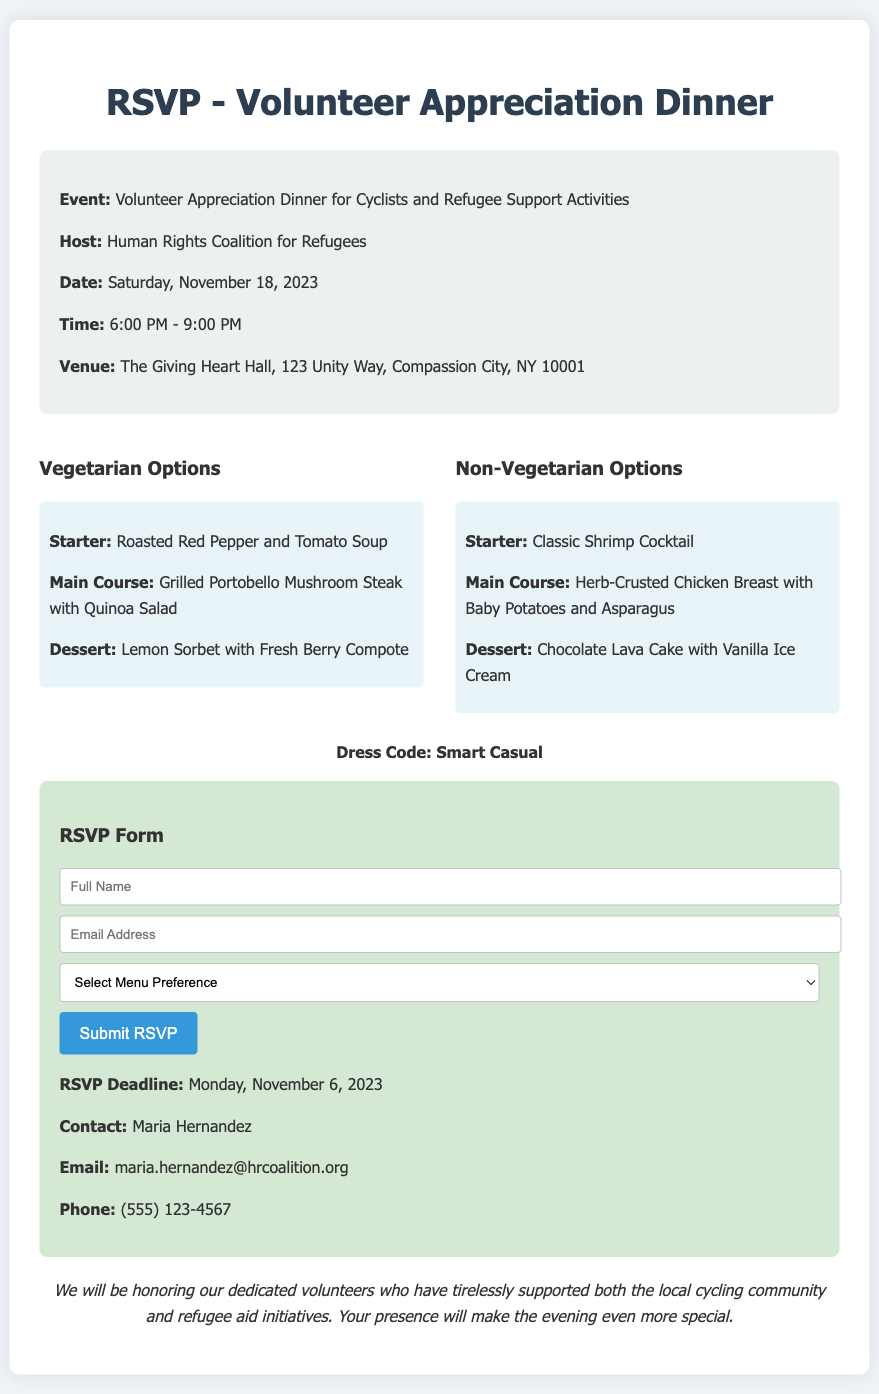What is the date of the event? The date of the event is mentioned in the event details section.
Answer: November 18, 2023 What is the venue for the dinner? The venue is stated in the event details section of the document.
Answer: The Giving Heart Hall, 123 Unity Way, Compassion City, NY 10001 Who is the host of the event? The host is listed in the event details section.
Answer: Human Rights Coalition for Refugees What is the RSVP deadline? The RSVP deadline is provided in the RSVP form section.
Answer: November 6, 2023 What are the main dishes available for vegetarians? The vegetarian main course option is described in the menu options section of the document.
Answer: Grilled Portobello Mushroom Steak with Quinoa Salad What type of meal is offered as a dessert for non-vegetarians? The dessert for non-vegetarians is included in the menu options section.
Answer: Chocolate Lava Cake with Vanilla Ice Cream How long will the event last? The duration of the event can be found in the event details section.
Answer: 3 hours What is the dress code for the dinner? The dress code is specifically mentioned in the document.
Answer: Smart Casual What is required to submit the RSVP? The RSVP form mentions the required fields to complete the submission.
Answer: Full Name, Email Address, Menu Preference 